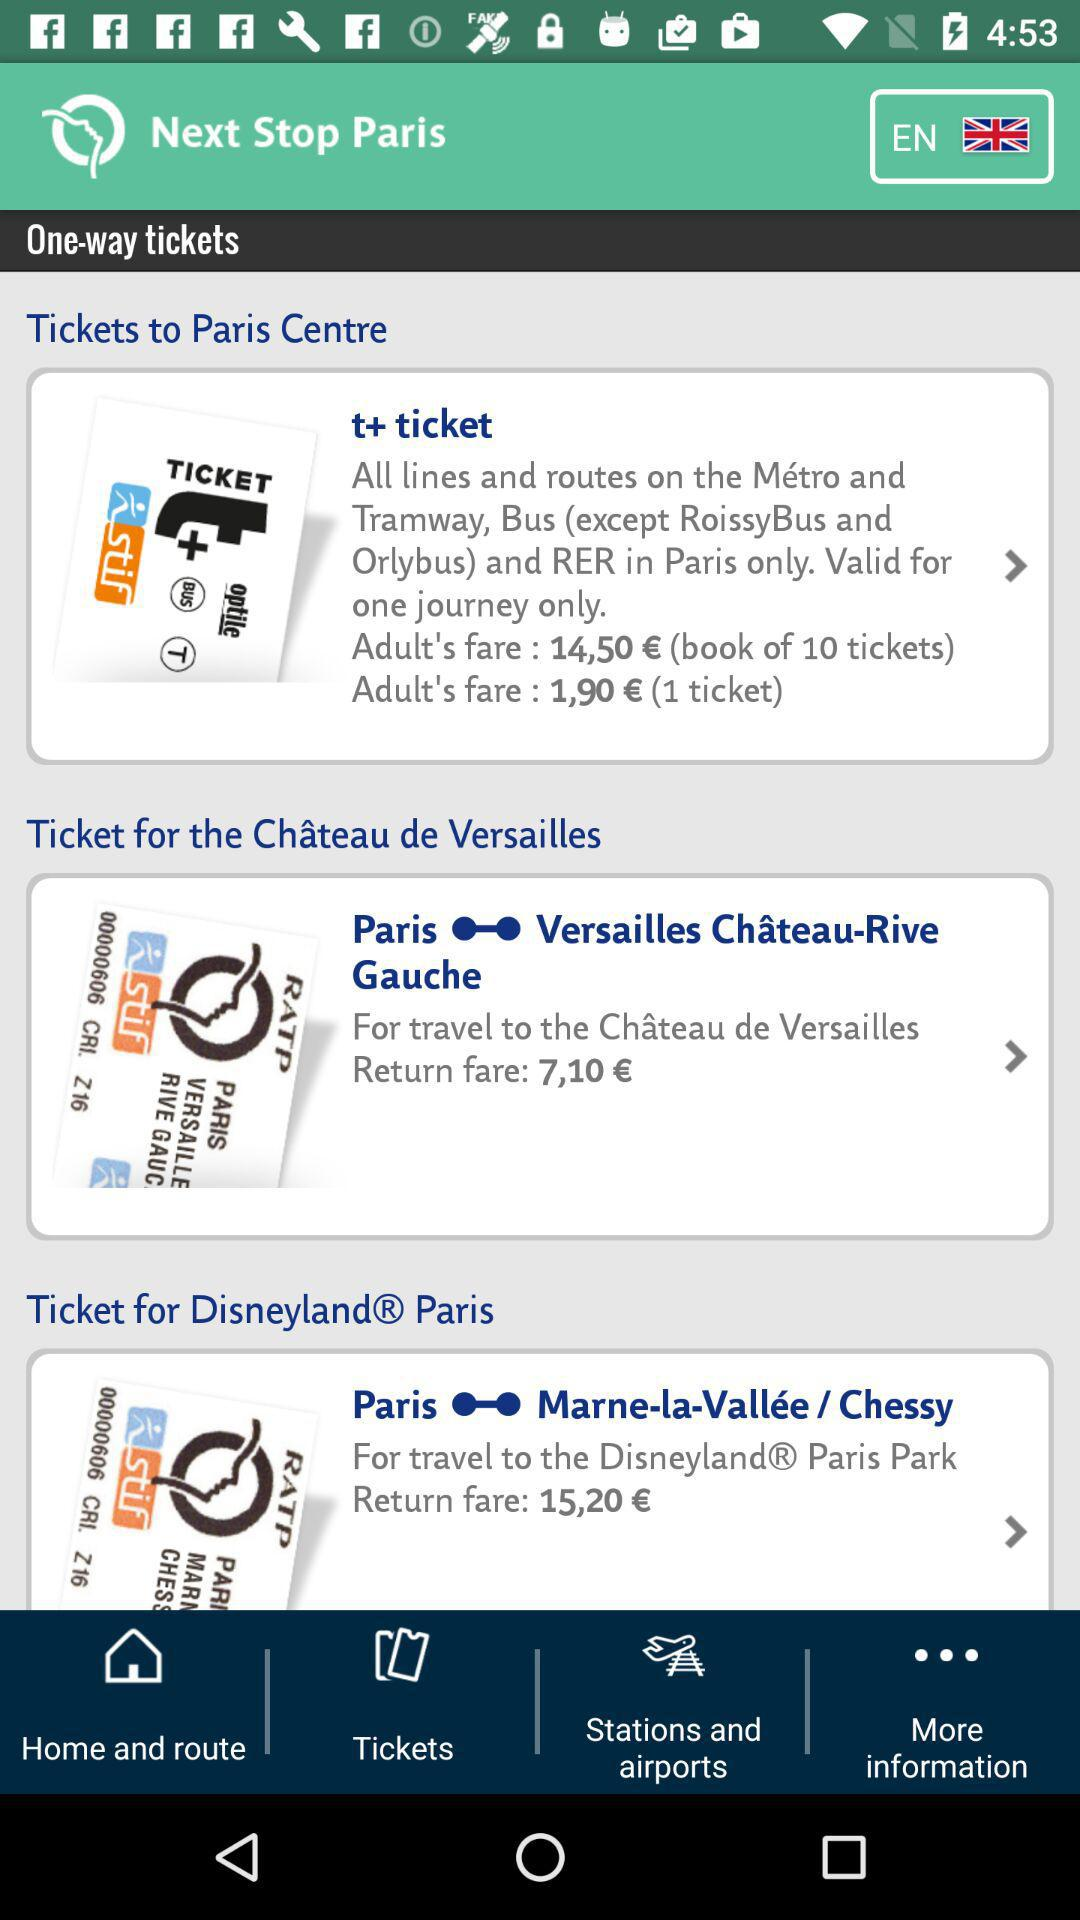What is the fare for one adult ticket in "t+ ticket"? The fare is 1,90 €. 